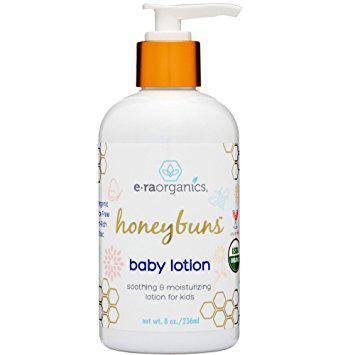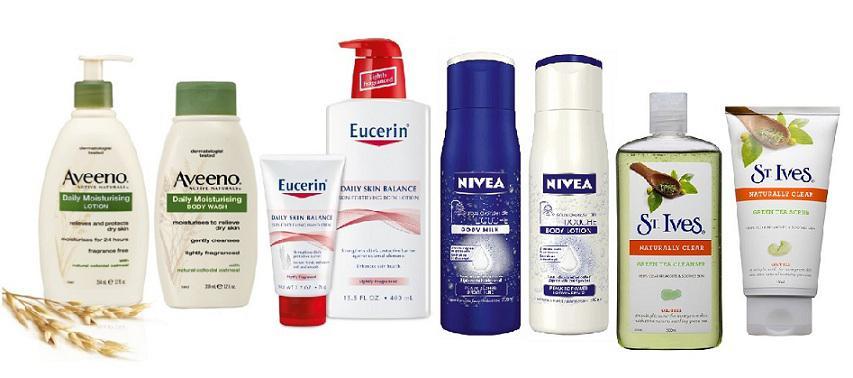The first image is the image on the left, the second image is the image on the right. Analyze the images presented: Is the assertion "In at least one image there is a total of two wash bottles." valid? Answer yes or no. No. The first image is the image on the left, the second image is the image on the right. Examine the images to the left and right. Is the description "The lefthand image includes a pump-applicator bottle, while the right image contains at least four versions of one product that doesn't have a pump top." accurate? Answer yes or no. No. 